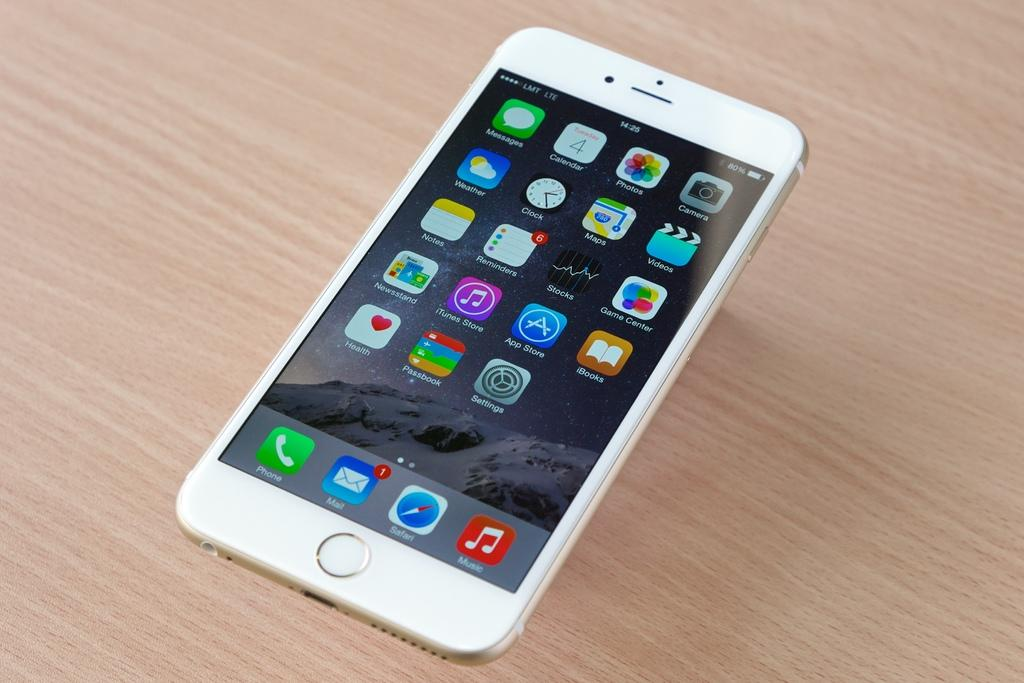<image>
Summarize the visual content of the image. a white cellphone on the LMT LTE service on a wood table 